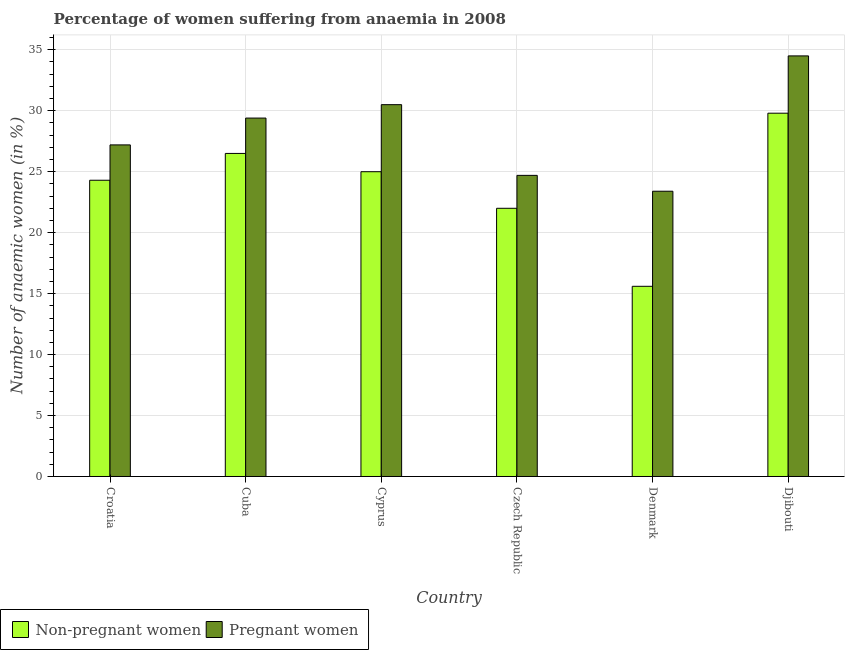How many different coloured bars are there?
Offer a very short reply. 2. How many groups of bars are there?
Offer a terse response. 6. How many bars are there on the 5th tick from the left?
Your answer should be very brief. 2. What is the label of the 5th group of bars from the left?
Provide a short and direct response. Denmark. What is the percentage of pregnant anaemic women in Cyprus?
Your answer should be very brief. 30.5. Across all countries, what is the maximum percentage of non-pregnant anaemic women?
Keep it short and to the point. 29.8. Across all countries, what is the minimum percentage of non-pregnant anaemic women?
Your answer should be compact. 15.6. In which country was the percentage of non-pregnant anaemic women maximum?
Give a very brief answer. Djibouti. What is the total percentage of pregnant anaemic women in the graph?
Your response must be concise. 169.7. What is the difference between the percentage of pregnant anaemic women in Cuba and that in Djibouti?
Offer a very short reply. -5.1. What is the difference between the percentage of pregnant anaemic women in Croatia and the percentage of non-pregnant anaemic women in Cyprus?
Offer a terse response. 2.2. What is the average percentage of pregnant anaemic women per country?
Provide a succinct answer. 28.28. What is the difference between the percentage of pregnant anaemic women and percentage of non-pregnant anaemic women in Czech Republic?
Provide a short and direct response. 2.7. What is the ratio of the percentage of pregnant anaemic women in Cuba to that in Denmark?
Provide a short and direct response. 1.26. Is the difference between the percentage of non-pregnant anaemic women in Croatia and Cyprus greater than the difference between the percentage of pregnant anaemic women in Croatia and Cyprus?
Make the answer very short. Yes. What is the difference between the highest and the second highest percentage of non-pregnant anaemic women?
Your answer should be compact. 3.3. What is the difference between the highest and the lowest percentage of non-pregnant anaemic women?
Make the answer very short. 14.2. In how many countries, is the percentage of pregnant anaemic women greater than the average percentage of pregnant anaemic women taken over all countries?
Your answer should be very brief. 3. Is the sum of the percentage of non-pregnant anaemic women in Croatia and Djibouti greater than the maximum percentage of pregnant anaemic women across all countries?
Offer a very short reply. Yes. What does the 2nd bar from the left in Denmark represents?
Keep it short and to the point. Pregnant women. What does the 1st bar from the right in Croatia represents?
Provide a short and direct response. Pregnant women. How many countries are there in the graph?
Keep it short and to the point. 6. Are the values on the major ticks of Y-axis written in scientific E-notation?
Keep it short and to the point. No. Does the graph contain grids?
Your response must be concise. Yes. What is the title of the graph?
Provide a succinct answer. Percentage of women suffering from anaemia in 2008. Does "Drinking water services" appear as one of the legend labels in the graph?
Keep it short and to the point. No. What is the label or title of the X-axis?
Offer a terse response. Country. What is the label or title of the Y-axis?
Provide a short and direct response. Number of anaemic women (in %). What is the Number of anaemic women (in %) of Non-pregnant women in Croatia?
Offer a terse response. 24.3. What is the Number of anaemic women (in %) of Pregnant women in Croatia?
Provide a succinct answer. 27.2. What is the Number of anaemic women (in %) in Pregnant women in Cuba?
Your answer should be very brief. 29.4. What is the Number of anaemic women (in %) in Pregnant women in Cyprus?
Ensure brevity in your answer.  30.5. What is the Number of anaemic women (in %) of Pregnant women in Czech Republic?
Offer a terse response. 24.7. What is the Number of anaemic women (in %) in Non-pregnant women in Denmark?
Ensure brevity in your answer.  15.6. What is the Number of anaemic women (in %) of Pregnant women in Denmark?
Your answer should be compact. 23.4. What is the Number of anaemic women (in %) in Non-pregnant women in Djibouti?
Ensure brevity in your answer.  29.8. What is the Number of anaemic women (in %) of Pregnant women in Djibouti?
Make the answer very short. 34.5. Across all countries, what is the maximum Number of anaemic women (in %) in Non-pregnant women?
Keep it short and to the point. 29.8. Across all countries, what is the maximum Number of anaemic women (in %) of Pregnant women?
Your response must be concise. 34.5. Across all countries, what is the minimum Number of anaemic women (in %) of Non-pregnant women?
Make the answer very short. 15.6. Across all countries, what is the minimum Number of anaemic women (in %) of Pregnant women?
Offer a terse response. 23.4. What is the total Number of anaemic women (in %) of Non-pregnant women in the graph?
Provide a succinct answer. 143.2. What is the total Number of anaemic women (in %) of Pregnant women in the graph?
Your response must be concise. 169.7. What is the difference between the Number of anaemic women (in %) of Non-pregnant women in Croatia and that in Cuba?
Provide a succinct answer. -2.2. What is the difference between the Number of anaemic women (in %) in Non-pregnant women in Croatia and that in Cyprus?
Provide a succinct answer. -0.7. What is the difference between the Number of anaemic women (in %) in Non-pregnant women in Croatia and that in Djibouti?
Offer a very short reply. -5.5. What is the difference between the Number of anaemic women (in %) of Non-pregnant women in Cuba and that in Cyprus?
Make the answer very short. 1.5. What is the difference between the Number of anaemic women (in %) in Non-pregnant women in Cuba and that in Czech Republic?
Your response must be concise. 4.5. What is the difference between the Number of anaemic women (in %) of Non-pregnant women in Cuba and that in Djibouti?
Provide a short and direct response. -3.3. What is the difference between the Number of anaemic women (in %) of Non-pregnant women in Cyprus and that in Denmark?
Your answer should be compact. 9.4. What is the difference between the Number of anaemic women (in %) of Non-pregnant women in Cyprus and that in Djibouti?
Provide a short and direct response. -4.8. What is the difference between the Number of anaemic women (in %) of Non-pregnant women in Czech Republic and that in Denmark?
Keep it short and to the point. 6.4. What is the difference between the Number of anaemic women (in %) in Pregnant women in Czech Republic and that in Denmark?
Provide a succinct answer. 1.3. What is the difference between the Number of anaemic women (in %) in Non-pregnant women in Czech Republic and that in Djibouti?
Your response must be concise. -7.8. What is the difference between the Number of anaemic women (in %) in Pregnant women in Czech Republic and that in Djibouti?
Provide a succinct answer. -9.8. What is the difference between the Number of anaemic women (in %) of Non-pregnant women in Croatia and the Number of anaemic women (in %) of Pregnant women in Cuba?
Provide a short and direct response. -5.1. What is the difference between the Number of anaemic women (in %) of Non-pregnant women in Cuba and the Number of anaemic women (in %) of Pregnant women in Denmark?
Your response must be concise. 3.1. What is the difference between the Number of anaemic women (in %) in Non-pregnant women in Cuba and the Number of anaemic women (in %) in Pregnant women in Djibouti?
Offer a terse response. -8. What is the difference between the Number of anaemic women (in %) of Non-pregnant women in Cyprus and the Number of anaemic women (in %) of Pregnant women in Czech Republic?
Provide a short and direct response. 0.3. What is the difference between the Number of anaemic women (in %) of Non-pregnant women in Cyprus and the Number of anaemic women (in %) of Pregnant women in Denmark?
Ensure brevity in your answer.  1.6. What is the difference between the Number of anaemic women (in %) in Non-pregnant women in Denmark and the Number of anaemic women (in %) in Pregnant women in Djibouti?
Offer a terse response. -18.9. What is the average Number of anaemic women (in %) in Non-pregnant women per country?
Offer a very short reply. 23.87. What is the average Number of anaemic women (in %) in Pregnant women per country?
Keep it short and to the point. 28.28. What is the difference between the Number of anaemic women (in %) of Non-pregnant women and Number of anaemic women (in %) of Pregnant women in Denmark?
Offer a terse response. -7.8. What is the difference between the Number of anaemic women (in %) in Non-pregnant women and Number of anaemic women (in %) in Pregnant women in Djibouti?
Offer a very short reply. -4.7. What is the ratio of the Number of anaemic women (in %) in Non-pregnant women in Croatia to that in Cuba?
Provide a short and direct response. 0.92. What is the ratio of the Number of anaemic women (in %) in Pregnant women in Croatia to that in Cuba?
Your response must be concise. 0.93. What is the ratio of the Number of anaemic women (in %) of Pregnant women in Croatia to that in Cyprus?
Ensure brevity in your answer.  0.89. What is the ratio of the Number of anaemic women (in %) of Non-pregnant women in Croatia to that in Czech Republic?
Offer a terse response. 1.1. What is the ratio of the Number of anaemic women (in %) in Pregnant women in Croatia to that in Czech Republic?
Provide a short and direct response. 1.1. What is the ratio of the Number of anaemic women (in %) of Non-pregnant women in Croatia to that in Denmark?
Your answer should be very brief. 1.56. What is the ratio of the Number of anaemic women (in %) in Pregnant women in Croatia to that in Denmark?
Offer a very short reply. 1.16. What is the ratio of the Number of anaemic women (in %) in Non-pregnant women in Croatia to that in Djibouti?
Your answer should be compact. 0.82. What is the ratio of the Number of anaemic women (in %) of Pregnant women in Croatia to that in Djibouti?
Make the answer very short. 0.79. What is the ratio of the Number of anaemic women (in %) of Non-pregnant women in Cuba to that in Cyprus?
Ensure brevity in your answer.  1.06. What is the ratio of the Number of anaemic women (in %) of Pregnant women in Cuba to that in Cyprus?
Provide a short and direct response. 0.96. What is the ratio of the Number of anaemic women (in %) of Non-pregnant women in Cuba to that in Czech Republic?
Provide a succinct answer. 1.2. What is the ratio of the Number of anaemic women (in %) in Pregnant women in Cuba to that in Czech Republic?
Provide a succinct answer. 1.19. What is the ratio of the Number of anaemic women (in %) in Non-pregnant women in Cuba to that in Denmark?
Your response must be concise. 1.7. What is the ratio of the Number of anaemic women (in %) in Pregnant women in Cuba to that in Denmark?
Offer a terse response. 1.26. What is the ratio of the Number of anaemic women (in %) in Non-pregnant women in Cuba to that in Djibouti?
Offer a very short reply. 0.89. What is the ratio of the Number of anaemic women (in %) of Pregnant women in Cuba to that in Djibouti?
Make the answer very short. 0.85. What is the ratio of the Number of anaemic women (in %) of Non-pregnant women in Cyprus to that in Czech Republic?
Your response must be concise. 1.14. What is the ratio of the Number of anaemic women (in %) in Pregnant women in Cyprus to that in Czech Republic?
Keep it short and to the point. 1.23. What is the ratio of the Number of anaemic women (in %) in Non-pregnant women in Cyprus to that in Denmark?
Your answer should be very brief. 1.6. What is the ratio of the Number of anaemic women (in %) of Pregnant women in Cyprus to that in Denmark?
Ensure brevity in your answer.  1.3. What is the ratio of the Number of anaemic women (in %) in Non-pregnant women in Cyprus to that in Djibouti?
Give a very brief answer. 0.84. What is the ratio of the Number of anaemic women (in %) in Pregnant women in Cyprus to that in Djibouti?
Offer a terse response. 0.88. What is the ratio of the Number of anaemic women (in %) in Non-pregnant women in Czech Republic to that in Denmark?
Offer a very short reply. 1.41. What is the ratio of the Number of anaemic women (in %) of Pregnant women in Czech Republic to that in Denmark?
Give a very brief answer. 1.06. What is the ratio of the Number of anaemic women (in %) of Non-pregnant women in Czech Republic to that in Djibouti?
Provide a short and direct response. 0.74. What is the ratio of the Number of anaemic women (in %) in Pregnant women in Czech Republic to that in Djibouti?
Your response must be concise. 0.72. What is the ratio of the Number of anaemic women (in %) in Non-pregnant women in Denmark to that in Djibouti?
Give a very brief answer. 0.52. What is the ratio of the Number of anaemic women (in %) of Pregnant women in Denmark to that in Djibouti?
Ensure brevity in your answer.  0.68. What is the difference between the highest and the second highest Number of anaemic women (in %) of Non-pregnant women?
Your answer should be very brief. 3.3. What is the difference between the highest and the second highest Number of anaemic women (in %) of Pregnant women?
Provide a short and direct response. 4. 